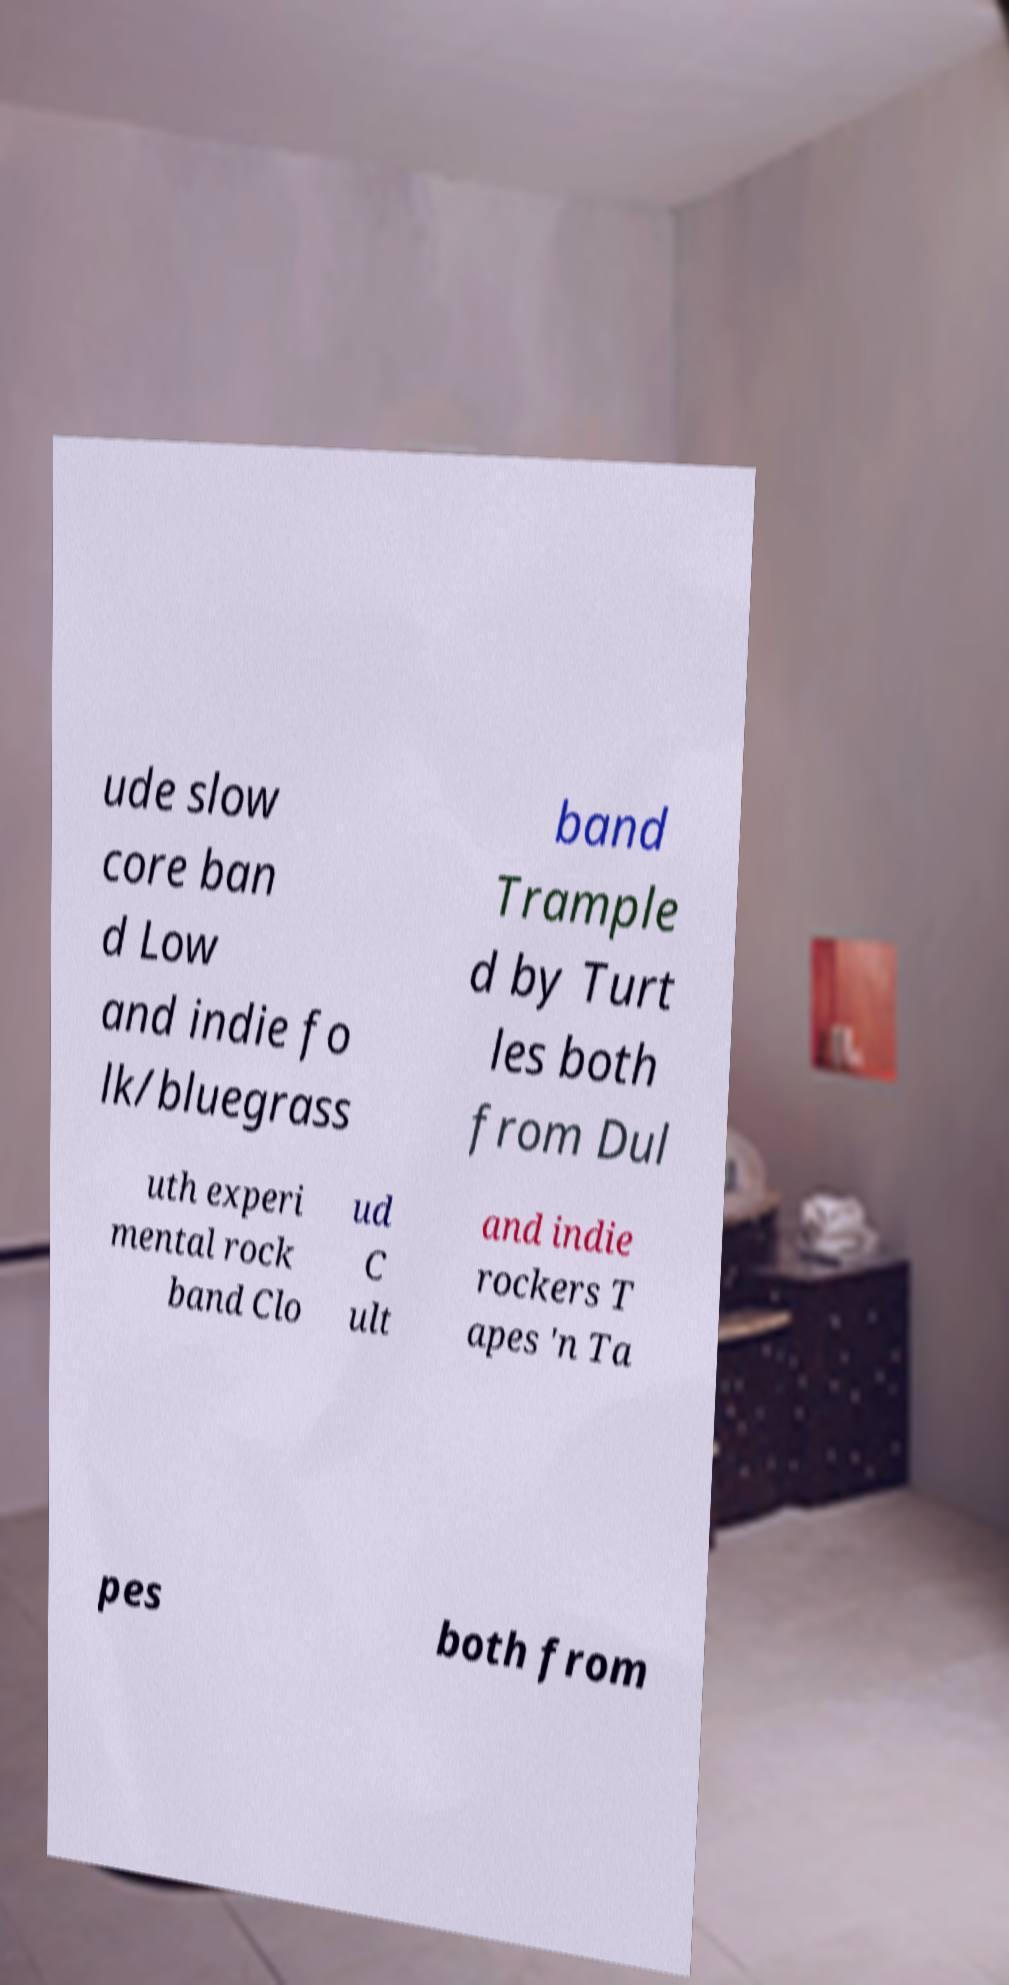Please read and relay the text visible in this image. What does it say? ude slow core ban d Low and indie fo lk/bluegrass band Trample d by Turt les both from Dul uth experi mental rock band Clo ud C ult and indie rockers T apes 'n Ta pes both from 